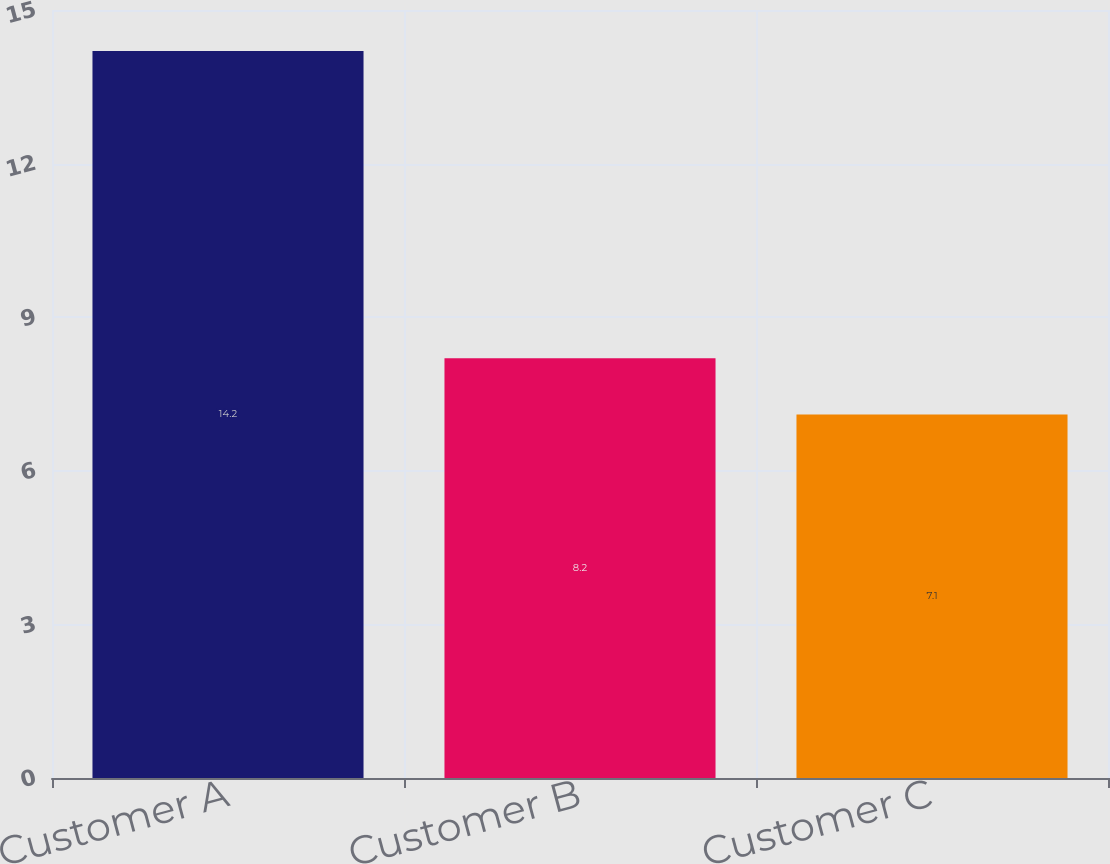Convert chart to OTSL. <chart><loc_0><loc_0><loc_500><loc_500><bar_chart><fcel>Customer A<fcel>Customer B<fcel>Customer C<nl><fcel>14.2<fcel>8.2<fcel>7.1<nl></chart> 